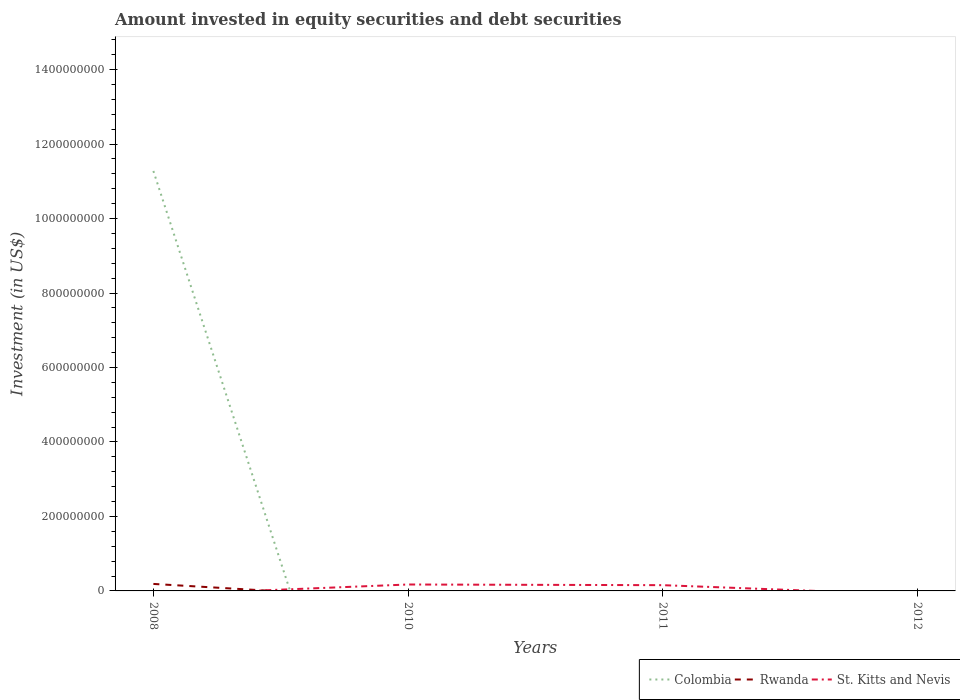How many different coloured lines are there?
Ensure brevity in your answer.  3. Is the number of lines equal to the number of legend labels?
Provide a short and direct response. No. Across all years, what is the maximum amount invested in equity securities and debt securities in Colombia?
Provide a short and direct response. 0. What is the total amount invested in equity securities and debt securities in St. Kitts and Nevis in the graph?
Offer a very short reply. 1.78e+06. What is the difference between the highest and the second highest amount invested in equity securities and debt securities in Rwanda?
Provide a succinct answer. 1.88e+07. How many years are there in the graph?
Your response must be concise. 4. What is the difference between two consecutive major ticks on the Y-axis?
Your answer should be compact. 2.00e+08. Are the values on the major ticks of Y-axis written in scientific E-notation?
Offer a terse response. No. Does the graph contain grids?
Provide a succinct answer. No. How many legend labels are there?
Keep it short and to the point. 3. How are the legend labels stacked?
Your answer should be very brief. Horizontal. What is the title of the graph?
Keep it short and to the point. Amount invested in equity securities and debt securities. Does "High income" appear as one of the legend labels in the graph?
Keep it short and to the point. No. What is the label or title of the Y-axis?
Your response must be concise. Investment (in US$). What is the Investment (in US$) in Colombia in 2008?
Give a very brief answer. 1.13e+09. What is the Investment (in US$) in Rwanda in 2008?
Give a very brief answer. 1.88e+07. What is the Investment (in US$) of St. Kitts and Nevis in 2008?
Your response must be concise. 0. What is the Investment (in US$) in Rwanda in 2010?
Your answer should be very brief. 0. What is the Investment (in US$) in St. Kitts and Nevis in 2010?
Make the answer very short. 1.72e+07. What is the Investment (in US$) in Colombia in 2011?
Provide a short and direct response. 0. What is the Investment (in US$) in St. Kitts and Nevis in 2011?
Make the answer very short. 1.55e+07. What is the Investment (in US$) in St. Kitts and Nevis in 2012?
Offer a terse response. 0. Across all years, what is the maximum Investment (in US$) in Colombia?
Provide a succinct answer. 1.13e+09. Across all years, what is the maximum Investment (in US$) in Rwanda?
Give a very brief answer. 1.88e+07. Across all years, what is the maximum Investment (in US$) in St. Kitts and Nevis?
Offer a terse response. 1.72e+07. Across all years, what is the minimum Investment (in US$) of St. Kitts and Nevis?
Give a very brief answer. 0. What is the total Investment (in US$) in Colombia in the graph?
Provide a short and direct response. 1.13e+09. What is the total Investment (in US$) of Rwanda in the graph?
Your answer should be very brief. 1.88e+07. What is the total Investment (in US$) in St. Kitts and Nevis in the graph?
Provide a short and direct response. 3.27e+07. What is the difference between the Investment (in US$) of St. Kitts and Nevis in 2010 and that in 2011?
Ensure brevity in your answer.  1.78e+06. What is the difference between the Investment (in US$) of Colombia in 2008 and the Investment (in US$) of St. Kitts and Nevis in 2010?
Your answer should be very brief. 1.11e+09. What is the difference between the Investment (in US$) of Rwanda in 2008 and the Investment (in US$) of St. Kitts and Nevis in 2010?
Provide a short and direct response. 1.55e+06. What is the difference between the Investment (in US$) in Colombia in 2008 and the Investment (in US$) in St. Kitts and Nevis in 2011?
Your answer should be compact. 1.11e+09. What is the difference between the Investment (in US$) in Rwanda in 2008 and the Investment (in US$) in St. Kitts and Nevis in 2011?
Offer a very short reply. 3.33e+06. What is the average Investment (in US$) of Colombia per year?
Offer a very short reply. 2.82e+08. What is the average Investment (in US$) in Rwanda per year?
Offer a terse response. 4.70e+06. What is the average Investment (in US$) in St. Kitts and Nevis per year?
Give a very brief answer. 8.18e+06. In the year 2008, what is the difference between the Investment (in US$) in Colombia and Investment (in US$) in Rwanda?
Give a very brief answer. 1.11e+09. What is the ratio of the Investment (in US$) of St. Kitts and Nevis in 2010 to that in 2011?
Your answer should be compact. 1.12. What is the difference between the highest and the lowest Investment (in US$) of Colombia?
Ensure brevity in your answer.  1.13e+09. What is the difference between the highest and the lowest Investment (in US$) of Rwanda?
Your answer should be compact. 1.88e+07. What is the difference between the highest and the lowest Investment (in US$) in St. Kitts and Nevis?
Keep it short and to the point. 1.72e+07. 